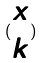<formula> <loc_0><loc_0><loc_500><loc_500>( \begin{matrix} x \\ k \end{matrix} )</formula> 